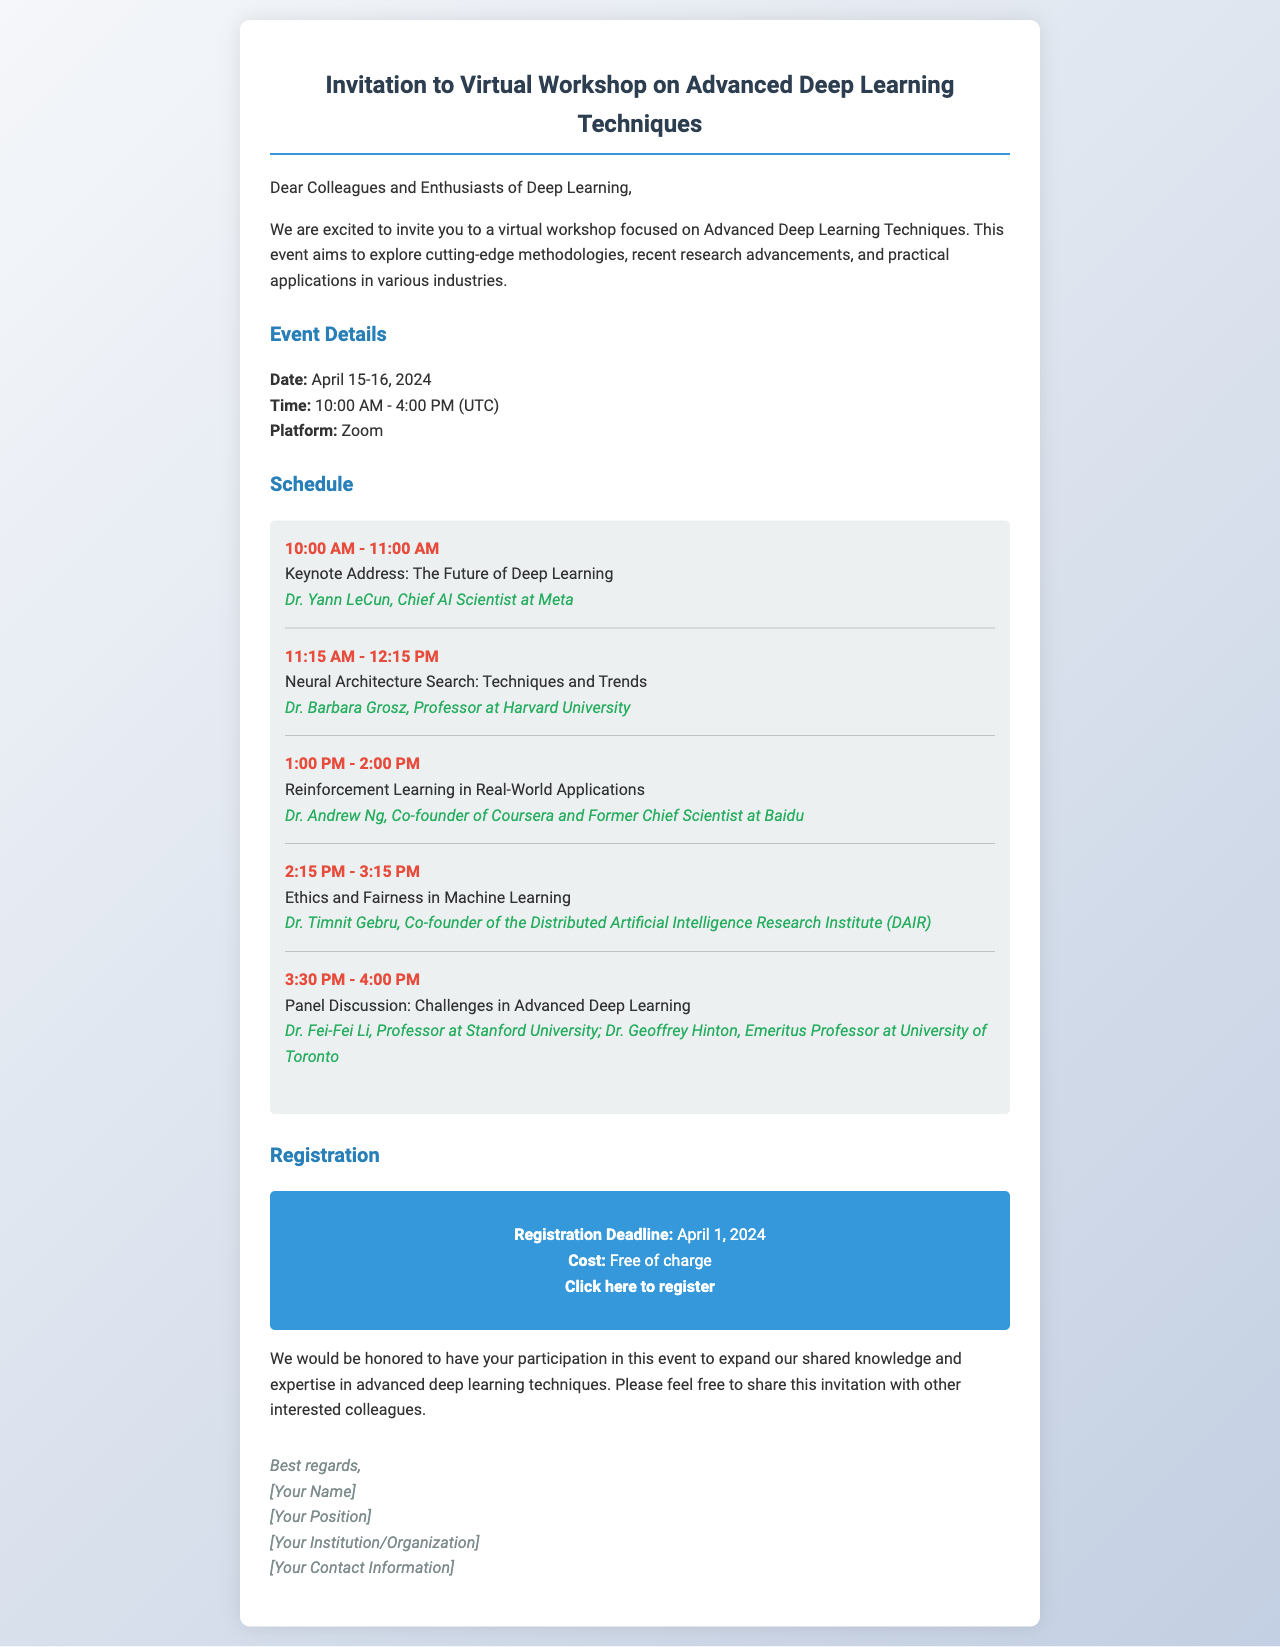What are the dates of the workshop? The dates of the workshop are directly mentioned in the event details section.
Answer: April 15-16, 2024 What time does the workshop start? The starting time is specifically indicated in the event details.
Answer: 10:00 AM Who is the keynote speaker? The keynote speaker's name and position are provided in the schedule.
Answer: Dr. Yann LeCun What topic does Dr. Timnit Gebru present on? The topic of Dr. Timnit Gebru's presentation is listed in the schedule.
Answer: Ethics and Fairness in Machine Learning What is the registration link? The registration link is explicitly included in the registration section.
Answer: https://www.example.com/registration How many speakers are featured in the schedule? The number of speakers can be counted from the schedule items listed.
Answer: 5 What is the cost of registration? The cost is clearly stated in the registration section of the document.
Answer: Free of charge What platform will the workshop be hosted on? The hosting platform is mentioned in the event details.
Answer: Zoom When is the registration deadline? The registration deadline is specified in the registration section.
Answer: April 1, 2024 